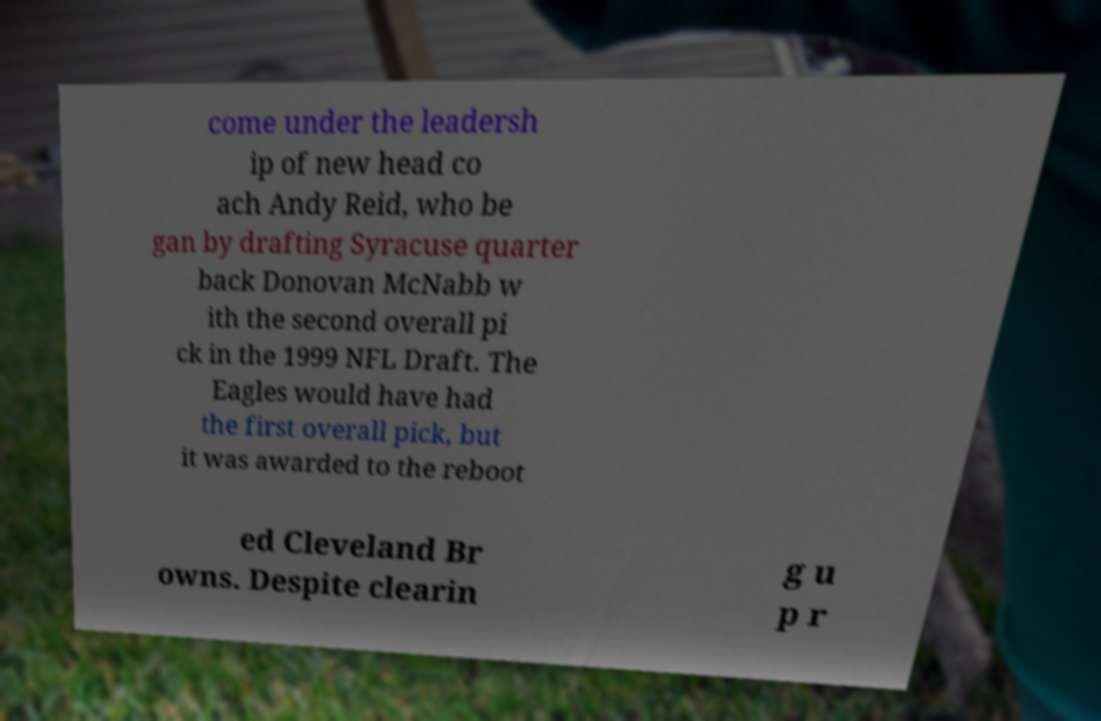Could you extract and type out the text from this image? come under the leadersh ip of new head co ach Andy Reid, who be gan by drafting Syracuse quarter back Donovan McNabb w ith the second overall pi ck in the 1999 NFL Draft. The Eagles would have had the first overall pick, but it was awarded to the reboot ed Cleveland Br owns. Despite clearin g u p r 